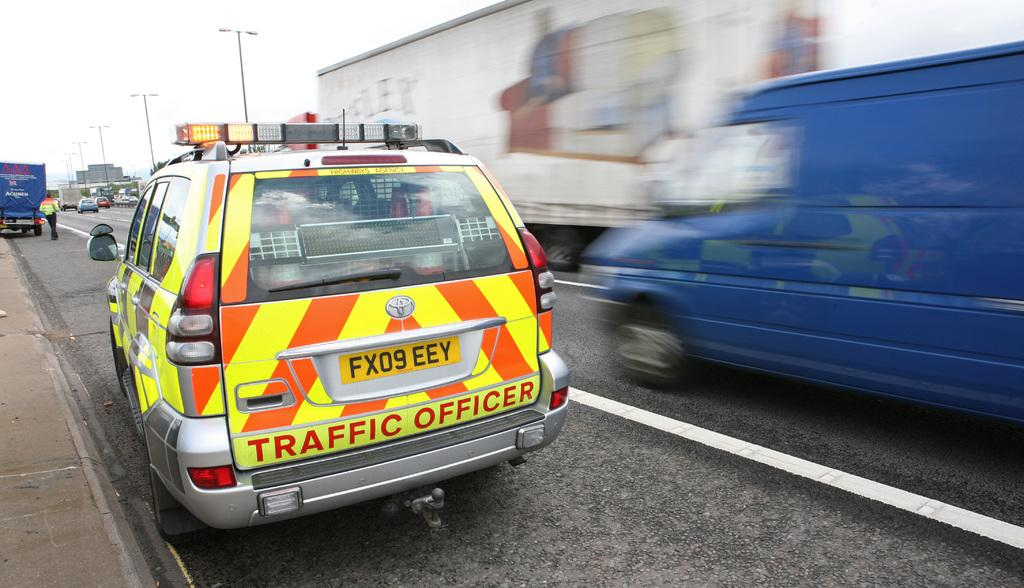<image>
Create a compact narrative representing the image presented. A orange and yellow, striped vehicle that is marked as a traffic officer, is parked on the side of the road. 